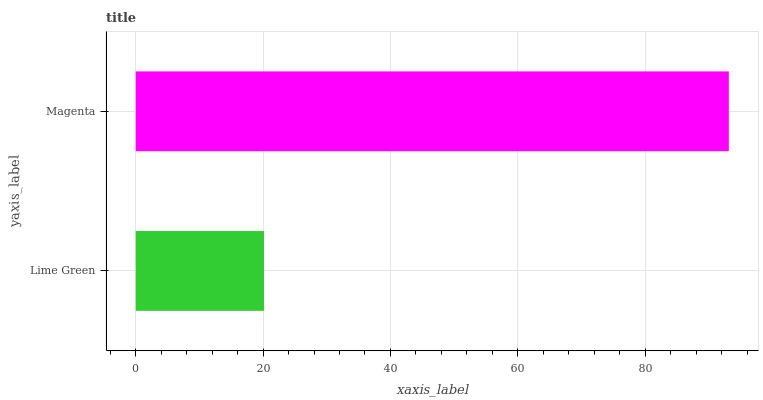Is Lime Green the minimum?
Answer yes or no. Yes. Is Magenta the maximum?
Answer yes or no. Yes. Is Magenta the minimum?
Answer yes or no. No. Is Magenta greater than Lime Green?
Answer yes or no. Yes. Is Lime Green less than Magenta?
Answer yes or no. Yes. Is Lime Green greater than Magenta?
Answer yes or no. No. Is Magenta less than Lime Green?
Answer yes or no. No. Is Magenta the high median?
Answer yes or no. Yes. Is Lime Green the low median?
Answer yes or no. Yes. Is Lime Green the high median?
Answer yes or no. No. Is Magenta the low median?
Answer yes or no. No. 